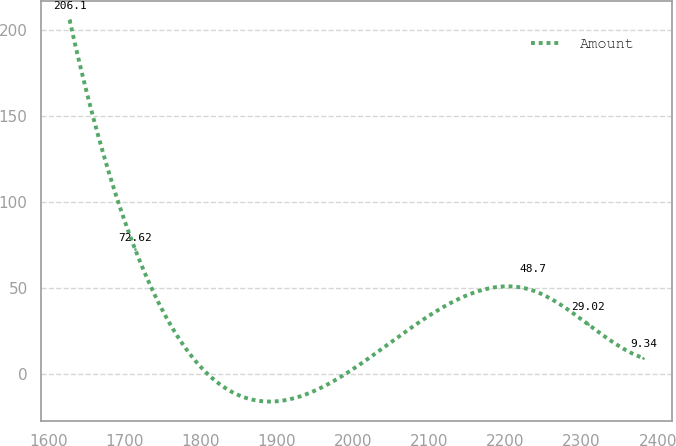Convert chart. <chart><loc_0><loc_0><loc_500><loc_500><line_chart><ecel><fcel>Amount<nl><fcel>1628.12<fcel>206.1<nl><fcel>1714.12<fcel>72.62<nl><fcel>2235.6<fcel>48.7<nl><fcel>2308.31<fcel>29.02<nl><fcel>2381.02<fcel>9.34<nl></chart> 